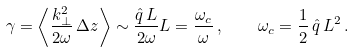<formula> <loc_0><loc_0><loc_500><loc_500>\gamma = \left \langle \frac { k _ { \perp } ^ { 2 } } { 2 \omega } \, \Delta z \right \rangle \sim \frac { \hat { q } \, L } { 2 \omega } L = \frac { \omega _ { c } } { \omega } \, , \quad \omega _ { c } = \frac { 1 } { 2 } \, \hat { q } \, L ^ { 2 } \, .</formula> 